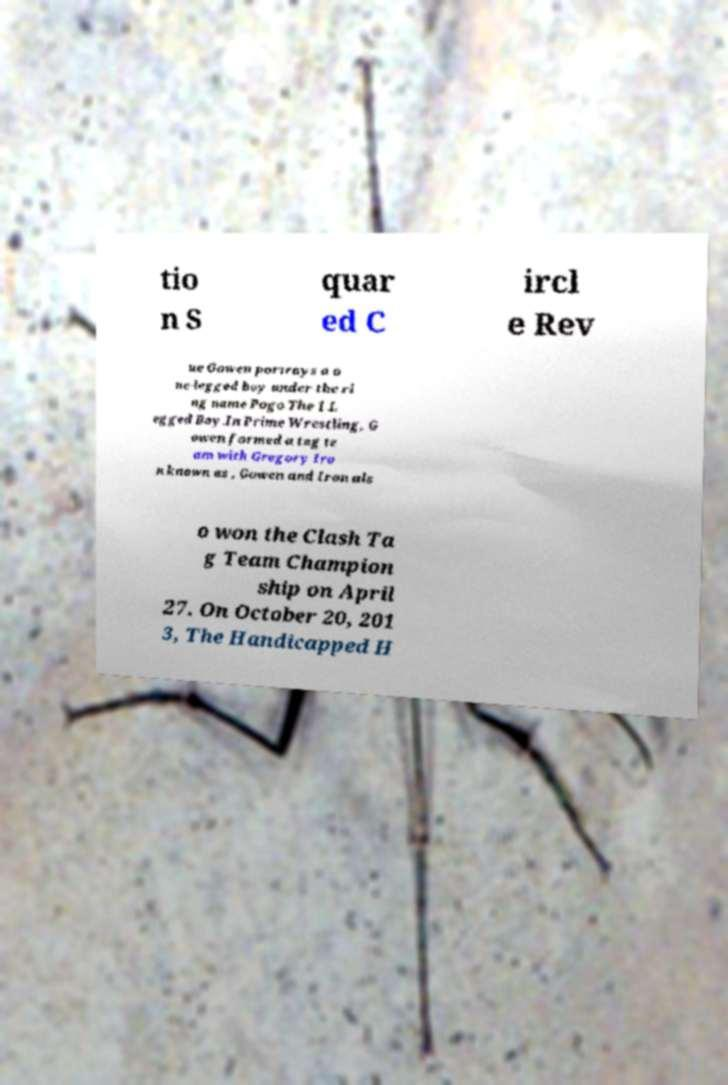I need the written content from this picture converted into text. Can you do that? tio n S quar ed C ircl e Rev ue Gowen portrays a o ne-legged boy under the ri ng name Pogo The 1 L egged Boy.In Prime Wrestling, G owen formed a tag te am with Gregory Iro n known as , Gowen and Iron als o won the Clash Ta g Team Champion ship on April 27. On October 20, 201 3, The Handicapped H 